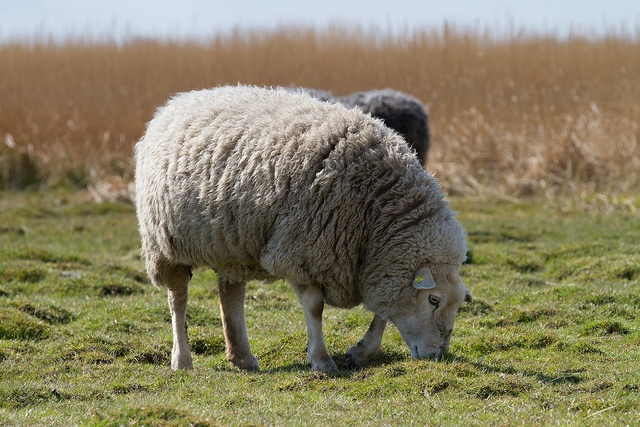Describe the objects in this image and their specific colors. I can see sheep in lavender, gray, black, and lightgray tones and sheep in lavender, black, darkgray, and gray tones in this image. 